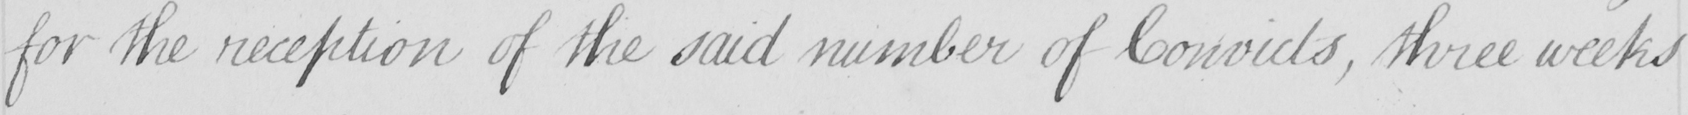Transcribe the text shown in this historical manuscript line. for the reception of the said number of Convicts , three weeks 